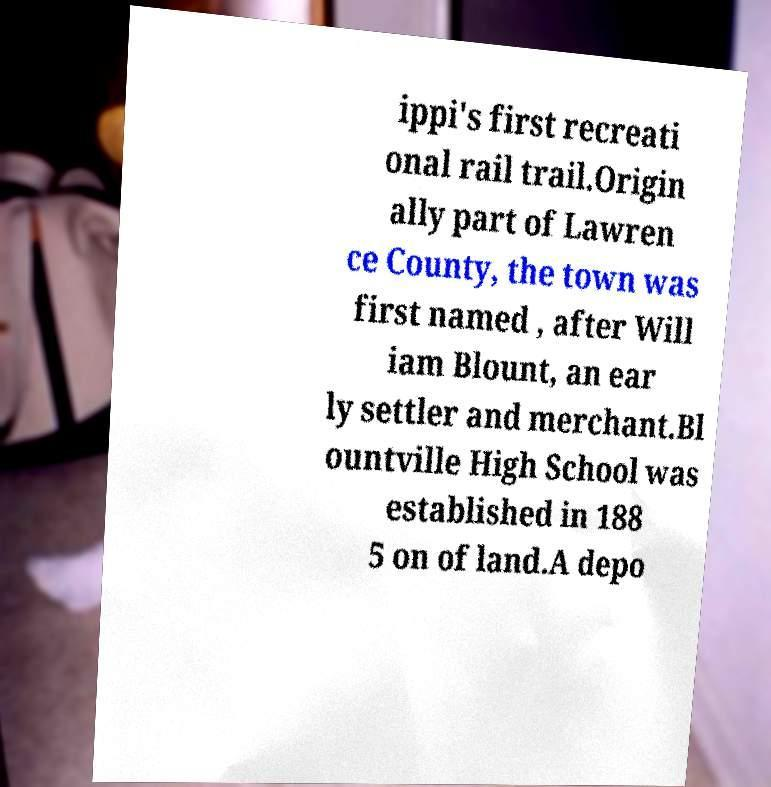There's text embedded in this image that I need extracted. Can you transcribe it verbatim? ippi's first recreati onal rail trail.Origin ally part of Lawren ce County, the town was first named , after Will iam Blount, an ear ly settler and merchant.Bl ountville High School was established in 188 5 on of land.A depo 